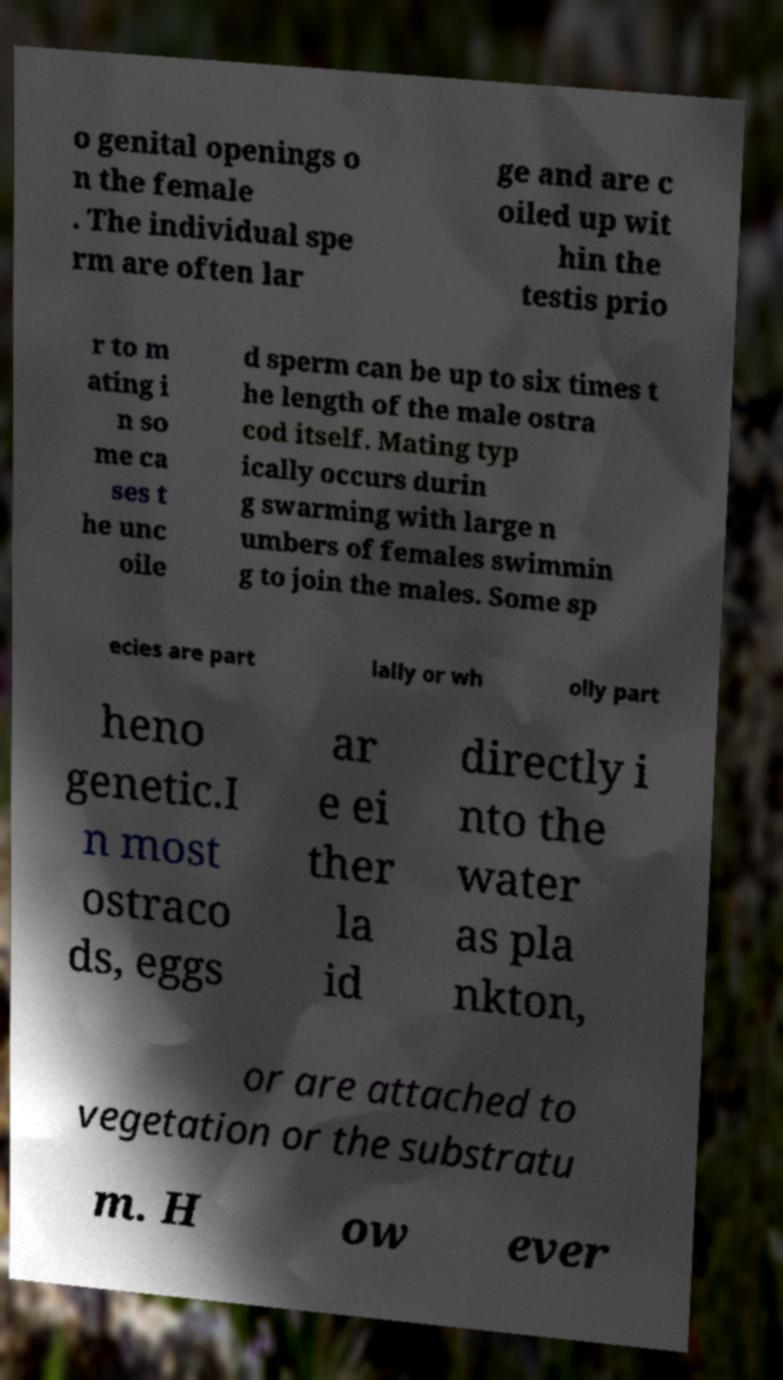Please identify and transcribe the text found in this image. o genital openings o n the female . The individual spe rm are often lar ge and are c oiled up wit hin the testis prio r to m ating i n so me ca ses t he unc oile d sperm can be up to six times t he length of the male ostra cod itself. Mating typ ically occurs durin g swarming with large n umbers of females swimmin g to join the males. Some sp ecies are part ially or wh olly part heno genetic.I n most ostraco ds, eggs ar e ei ther la id directly i nto the water as pla nkton, or are attached to vegetation or the substratu m. H ow ever 